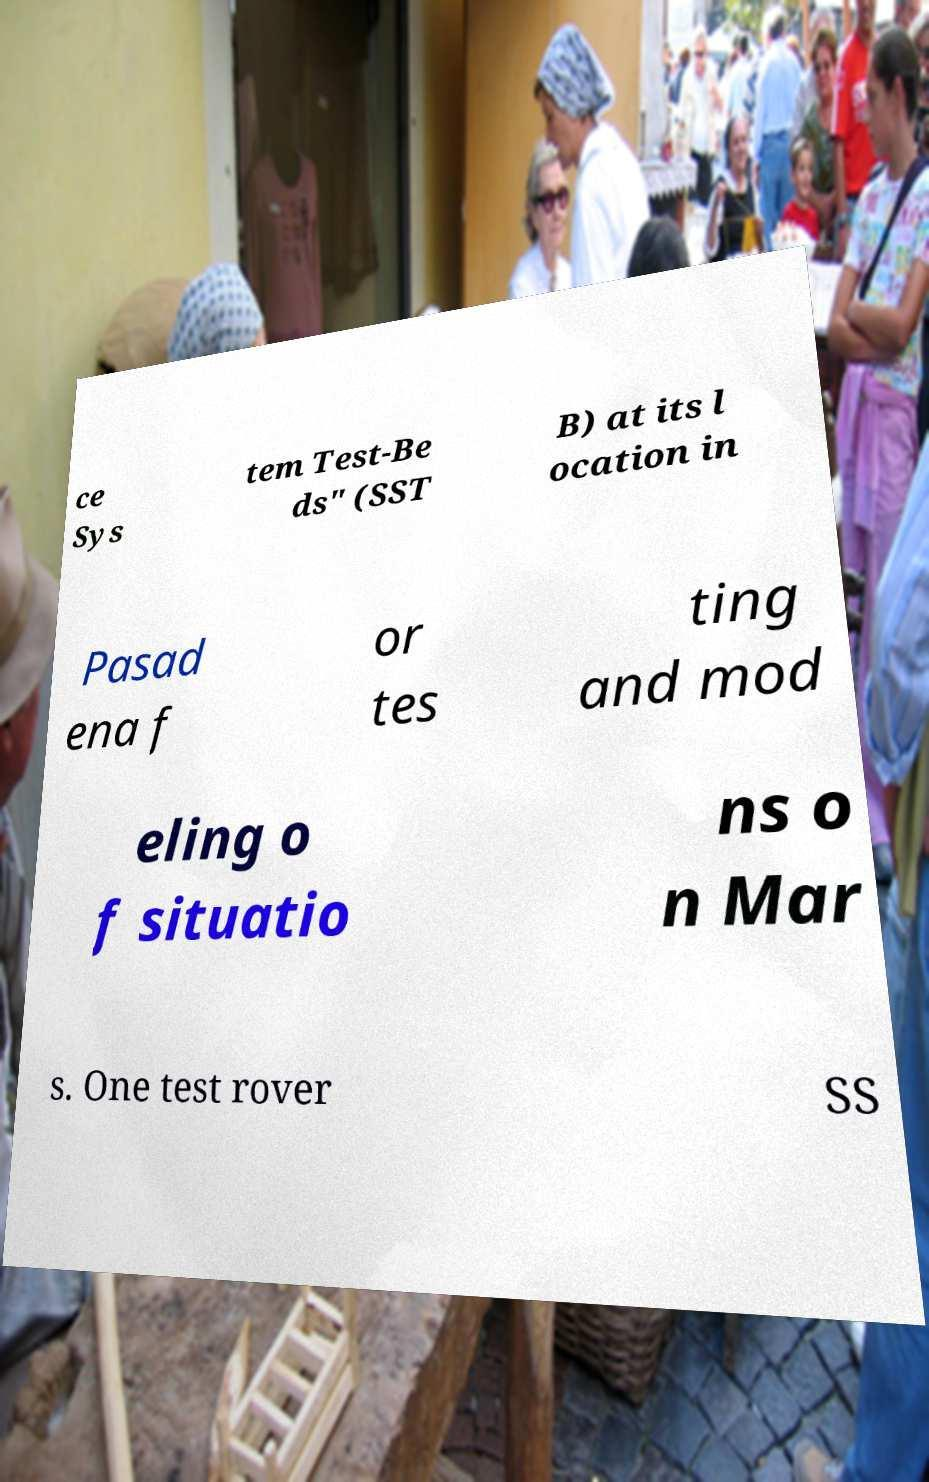I need the written content from this picture converted into text. Can you do that? ce Sys tem Test-Be ds" (SST B) at its l ocation in Pasad ena f or tes ting and mod eling o f situatio ns o n Mar s. One test rover SS 